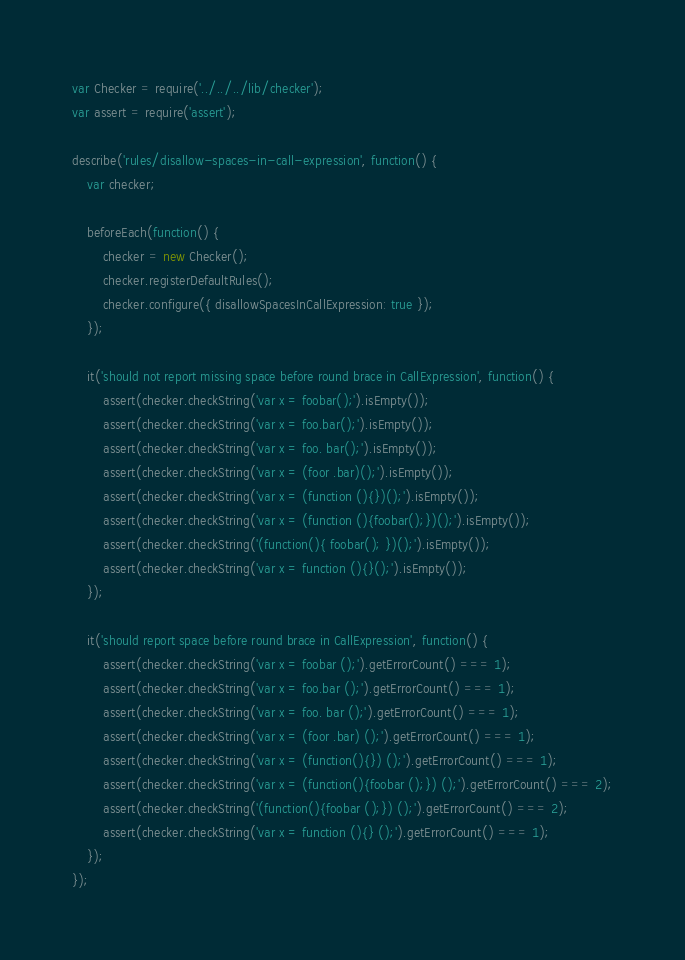<code> <loc_0><loc_0><loc_500><loc_500><_JavaScript_>var Checker = require('../../../lib/checker');
var assert = require('assert');

describe('rules/disallow-spaces-in-call-expression', function() {
    var checker;

    beforeEach(function() {
        checker = new Checker();
        checker.registerDefaultRules();
        checker.configure({ disallowSpacesInCallExpression: true });
    });

    it('should not report missing space before round brace in CallExpression', function() {
        assert(checker.checkString('var x = foobar();').isEmpty());
        assert(checker.checkString('var x = foo.bar();').isEmpty());
        assert(checker.checkString('var x = foo. bar();').isEmpty());
        assert(checker.checkString('var x = (foor .bar)();').isEmpty());
        assert(checker.checkString('var x = (function (){})();').isEmpty());
        assert(checker.checkString('var x = (function (){foobar();})();').isEmpty());
        assert(checker.checkString('(function(){ foobar(); })();').isEmpty());
        assert(checker.checkString('var x = function (){}();').isEmpty());
    });

    it('should report space before round brace in CallExpression', function() {
        assert(checker.checkString('var x = foobar ();').getErrorCount() === 1);
        assert(checker.checkString('var x = foo.bar ();').getErrorCount() === 1);
        assert(checker.checkString('var x = foo. bar ();').getErrorCount() === 1);
        assert(checker.checkString('var x = (foor .bar) ();').getErrorCount() === 1);
        assert(checker.checkString('var x = (function(){}) ();').getErrorCount() === 1);
        assert(checker.checkString('var x = (function(){foobar ();}) ();').getErrorCount() === 2);
        assert(checker.checkString('(function(){foobar ();}) ();').getErrorCount() === 2);
        assert(checker.checkString('var x = function (){} ();').getErrorCount() === 1);
    });
});
</code> 